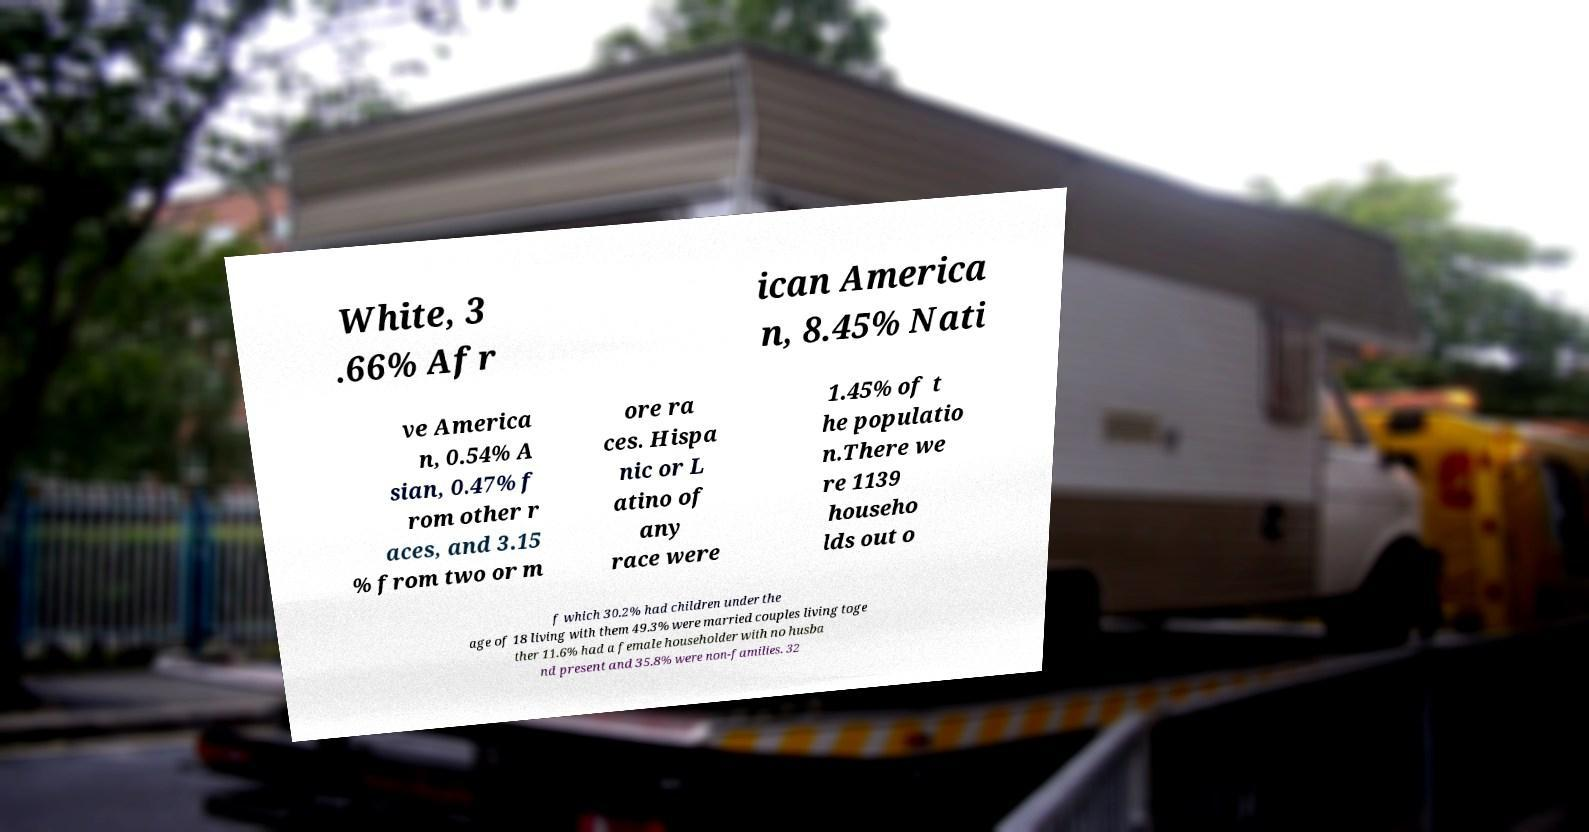Could you assist in decoding the text presented in this image and type it out clearly? White, 3 .66% Afr ican America n, 8.45% Nati ve America n, 0.54% A sian, 0.47% f rom other r aces, and 3.15 % from two or m ore ra ces. Hispa nic or L atino of any race were 1.45% of t he populatio n.There we re 1139 househo lds out o f which 30.2% had children under the age of 18 living with them 49.3% were married couples living toge ther 11.6% had a female householder with no husba nd present and 35.8% were non-families. 32 